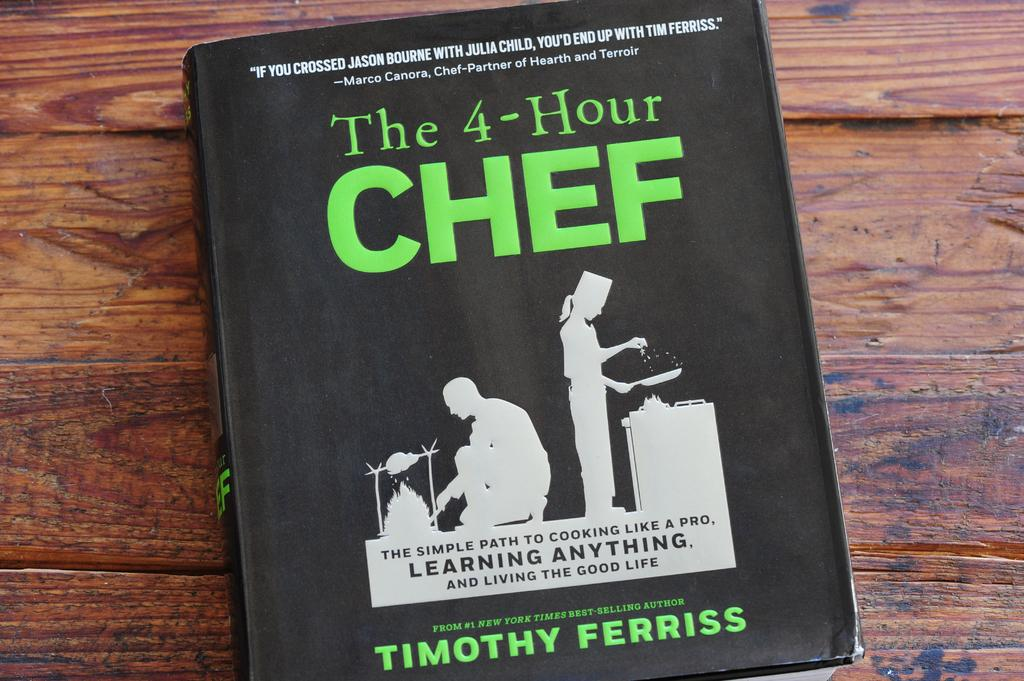<image>
Write a terse but informative summary of the picture. Book titled "The 4-Hour Chef" showing two people cooking. 